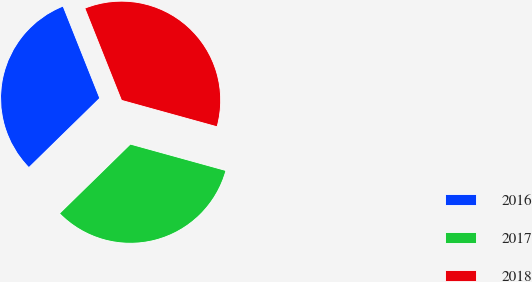Convert chart to OTSL. <chart><loc_0><loc_0><loc_500><loc_500><pie_chart><fcel>2016<fcel>2017<fcel>2018<nl><fcel>31.29%<fcel>33.38%<fcel>35.33%<nl></chart> 